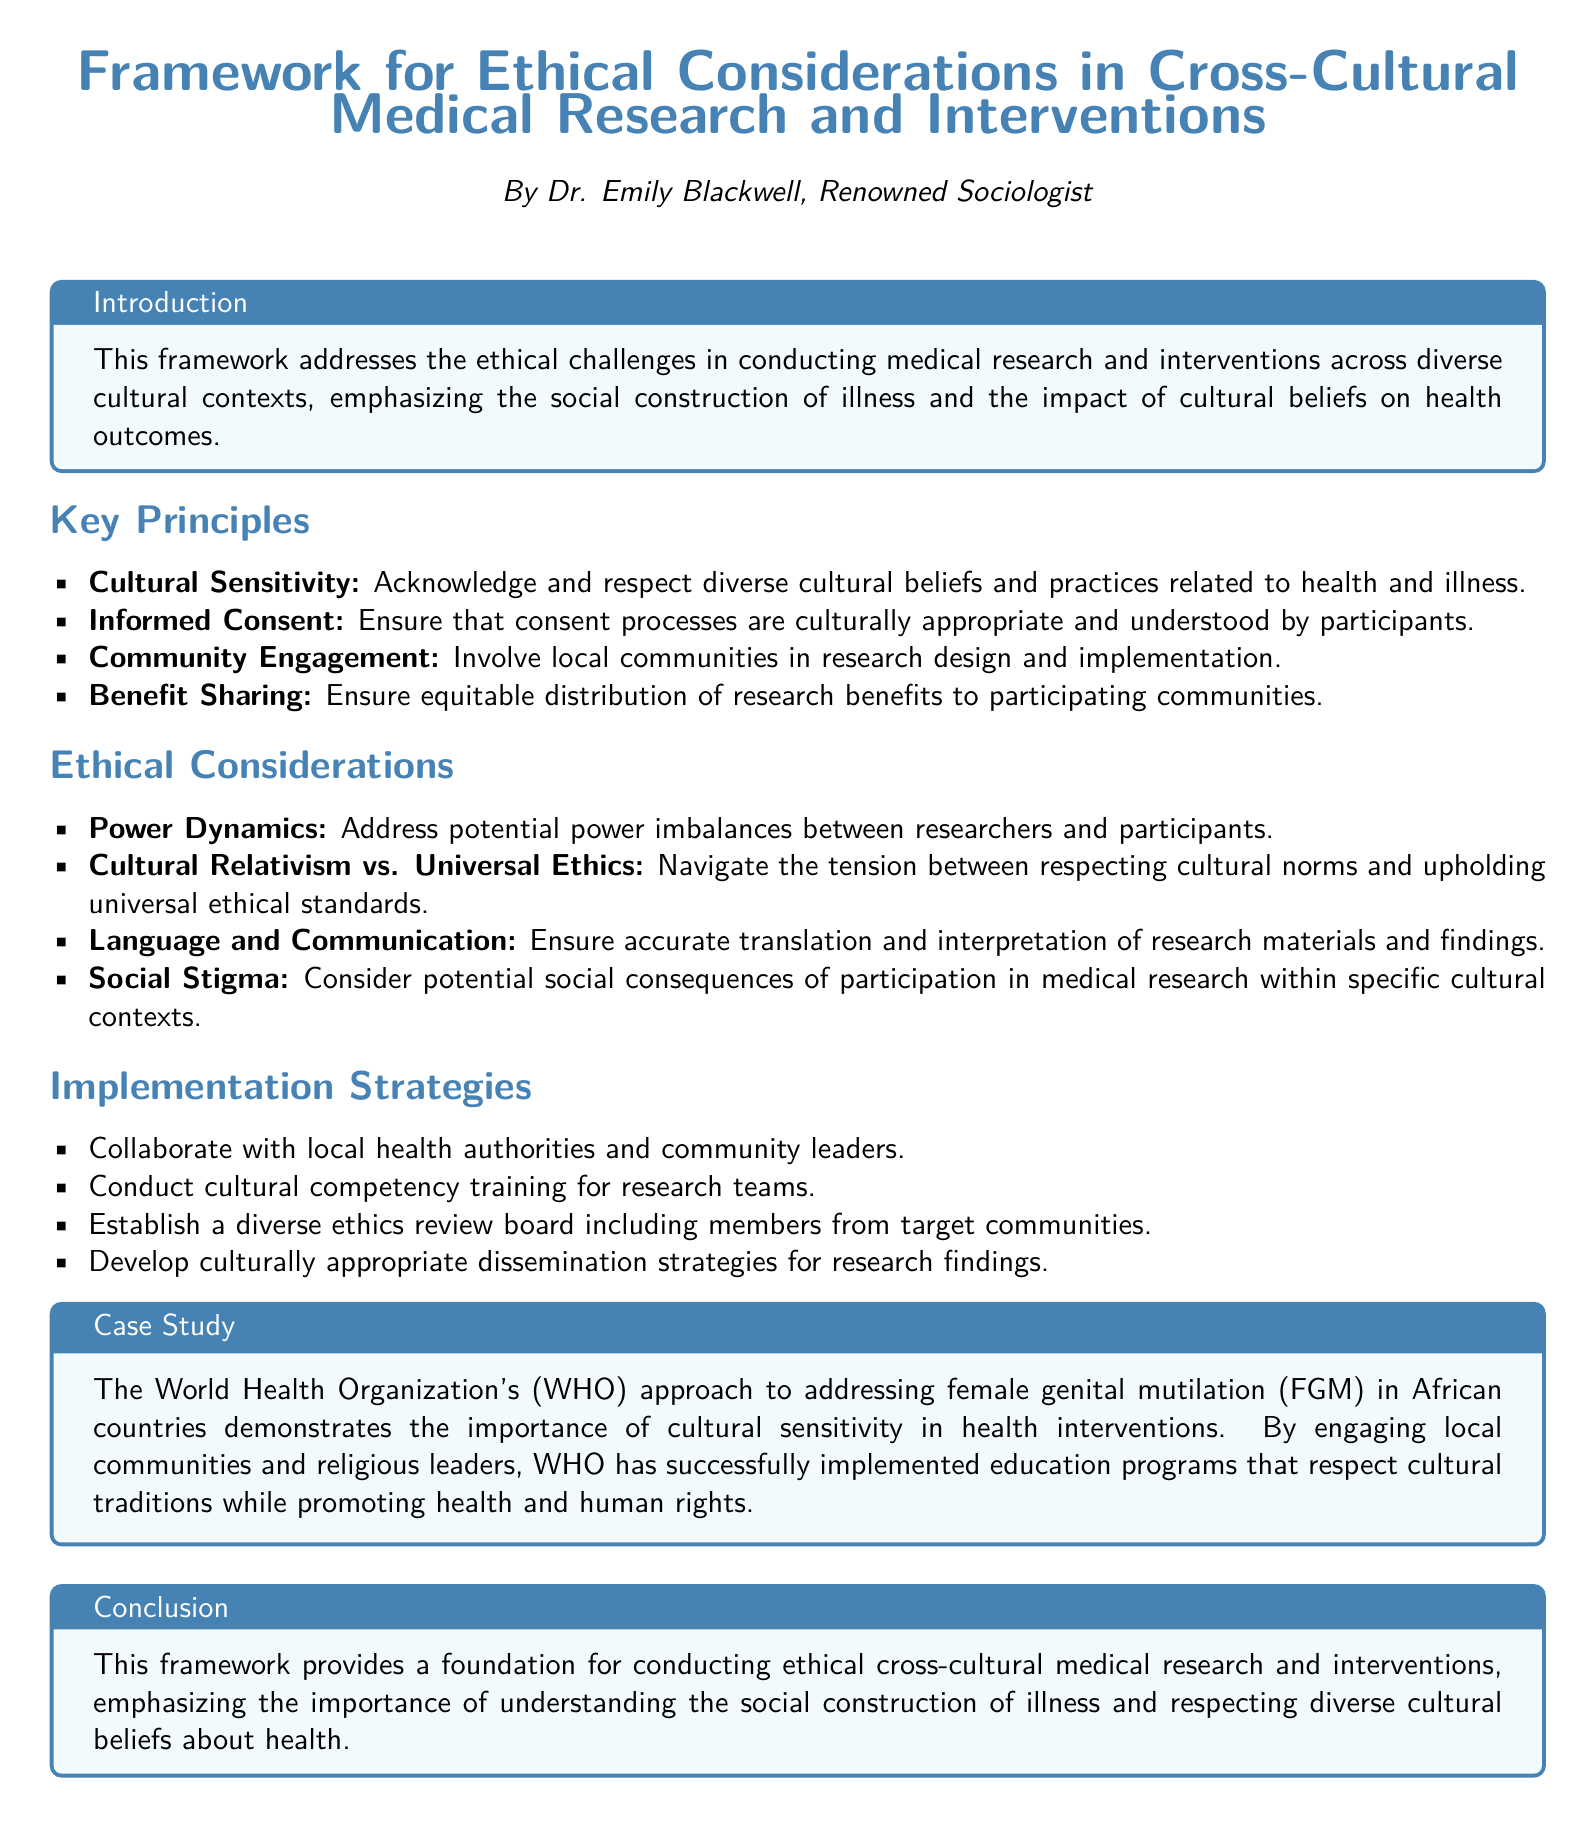what is the title of the document? The title is presented prominently at the top of the document, stating the focus of the framework.
Answer: Framework for Ethical Considerations in Cross-Cultural Medical Research and Interventions who is the author of the document? The document includes the author's name, indicating their role and expertise.
Answer: Dr. Emily Blackwell what is one key principle mentioned in the document? The document lists several key principles guiding ethical considerations, highlighting important aspects of research.
Answer: Cultural Sensitivity what ethical consideration addresses potential power imbalances? The document outlines specific ethical considerations related to the dynamics between researchers and participants.
Answer: Power Dynamics how many implementation strategies are listed in the document? The document enumerates strategies for effectively implementing the ethical framework.
Answer: Four which case study is mentioned in the document? The document provides an example involving an organization’s approach to a sensitive cultural issue in health.
Answer: The World Health Organization's approach to female genital mutilation what does the conclusion emphasize regarding cultural beliefs? The conclusion reflects on the significance of understanding cultural contexts in relation to health.
Answer: Respecting diverse cultural beliefs about health what is a strategy for community engagement mentioned in the document? The document suggests ways to involve the community in research processes to enhance relevance and acceptance.
Answer: Collaborate with local health authorities and community leaders what does the document say about informed consent? The document specifies an important ethical requirement related to participant involvement in medical research.
Answer: Ensure that consent processes are culturally appropriate and understood by participants 